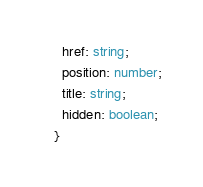Convert code to text. <code><loc_0><loc_0><loc_500><loc_500><_TypeScript_>  href: string;
  position: number;
  title: string;
  hidden: boolean;
}
</code> 